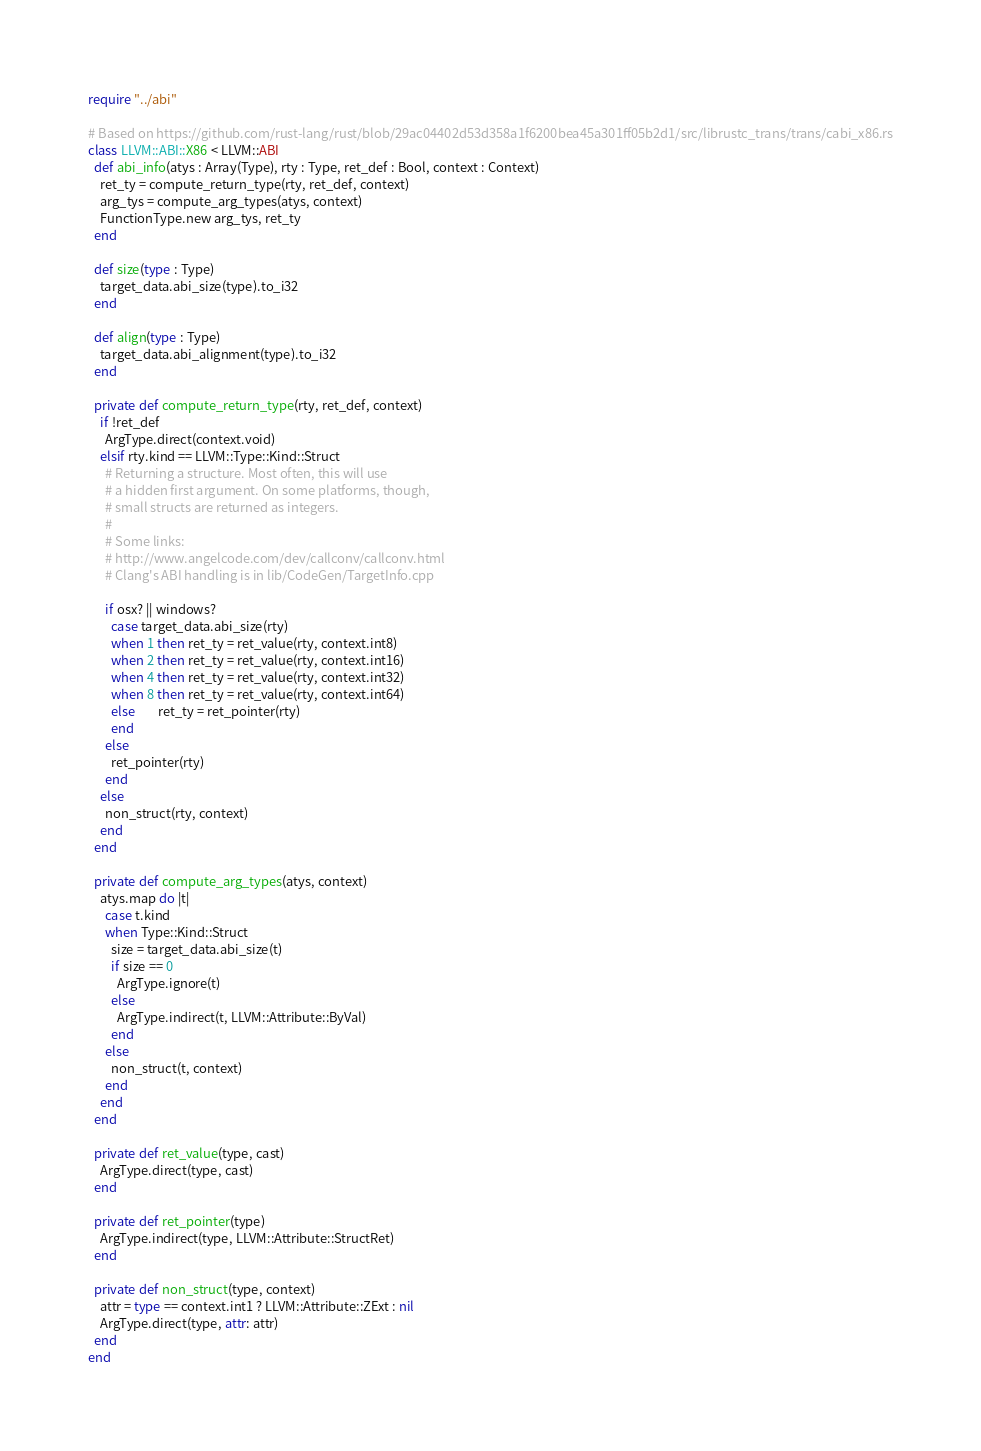<code> <loc_0><loc_0><loc_500><loc_500><_Crystal_>require "../abi"

# Based on https://github.com/rust-lang/rust/blob/29ac04402d53d358a1f6200bea45a301ff05b2d1/src/librustc_trans/trans/cabi_x86.rs
class LLVM::ABI::X86 < LLVM::ABI
  def abi_info(atys : Array(Type), rty : Type, ret_def : Bool, context : Context)
    ret_ty = compute_return_type(rty, ret_def, context)
    arg_tys = compute_arg_types(atys, context)
    FunctionType.new arg_tys, ret_ty
  end

  def size(type : Type)
    target_data.abi_size(type).to_i32
  end

  def align(type : Type)
    target_data.abi_alignment(type).to_i32
  end

  private def compute_return_type(rty, ret_def, context)
    if !ret_def
      ArgType.direct(context.void)
    elsif rty.kind == LLVM::Type::Kind::Struct
      # Returning a structure. Most often, this will use
      # a hidden first argument. On some platforms, though,
      # small structs are returned as integers.
      #
      # Some links:
      # http://www.angelcode.com/dev/callconv/callconv.html
      # Clang's ABI handling is in lib/CodeGen/TargetInfo.cpp

      if osx? || windows?
        case target_data.abi_size(rty)
        when 1 then ret_ty = ret_value(rty, context.int8)
        when 2 then ret_ty = ret_value(rty, context.int16)
        when 4 then ret_ty = ret_value(rty, context.int32)
        when 8 then ret_ty = ret_value(rty, context.int64)
        else        ret_ty = ret_pointer(rty)
        end
      else
        ret_pointer(rty)
      end
    else
      non_struct(rty, context)
    end
  end

  private def compute_arg_types(atys, context)
    atys.map do |t|
      case t.kind
      when Type::Kind::Struct
        size = target_data.abi_size(t)
        if size == 0
          ArgType.ignore(t)
        else
          ArgType.indirect(t, LLVM::Attribute::ByVal)
        end
      else
        non_struct(t, context)
      end
    end
  end

  private def ret_value(type, cast)
    ArgType.direct(type, cast)
  end

  private def ret_pointer(type)
    ArgType.indirect(type, LLVM::Attribute::StructRet)
  end

  private def non_struct(type, context)
    attr = type == context.int1 ? LLVM::Attribute::ZExt : nil
    ArgType.direct(type, attr: attr)
  end
end
</code> 